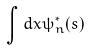Convert formula to latex. <formula><loc_0><loc_0><loc_500><loc_500>\int d x \psi _ { n } ^ { * } ( s )</formula> 